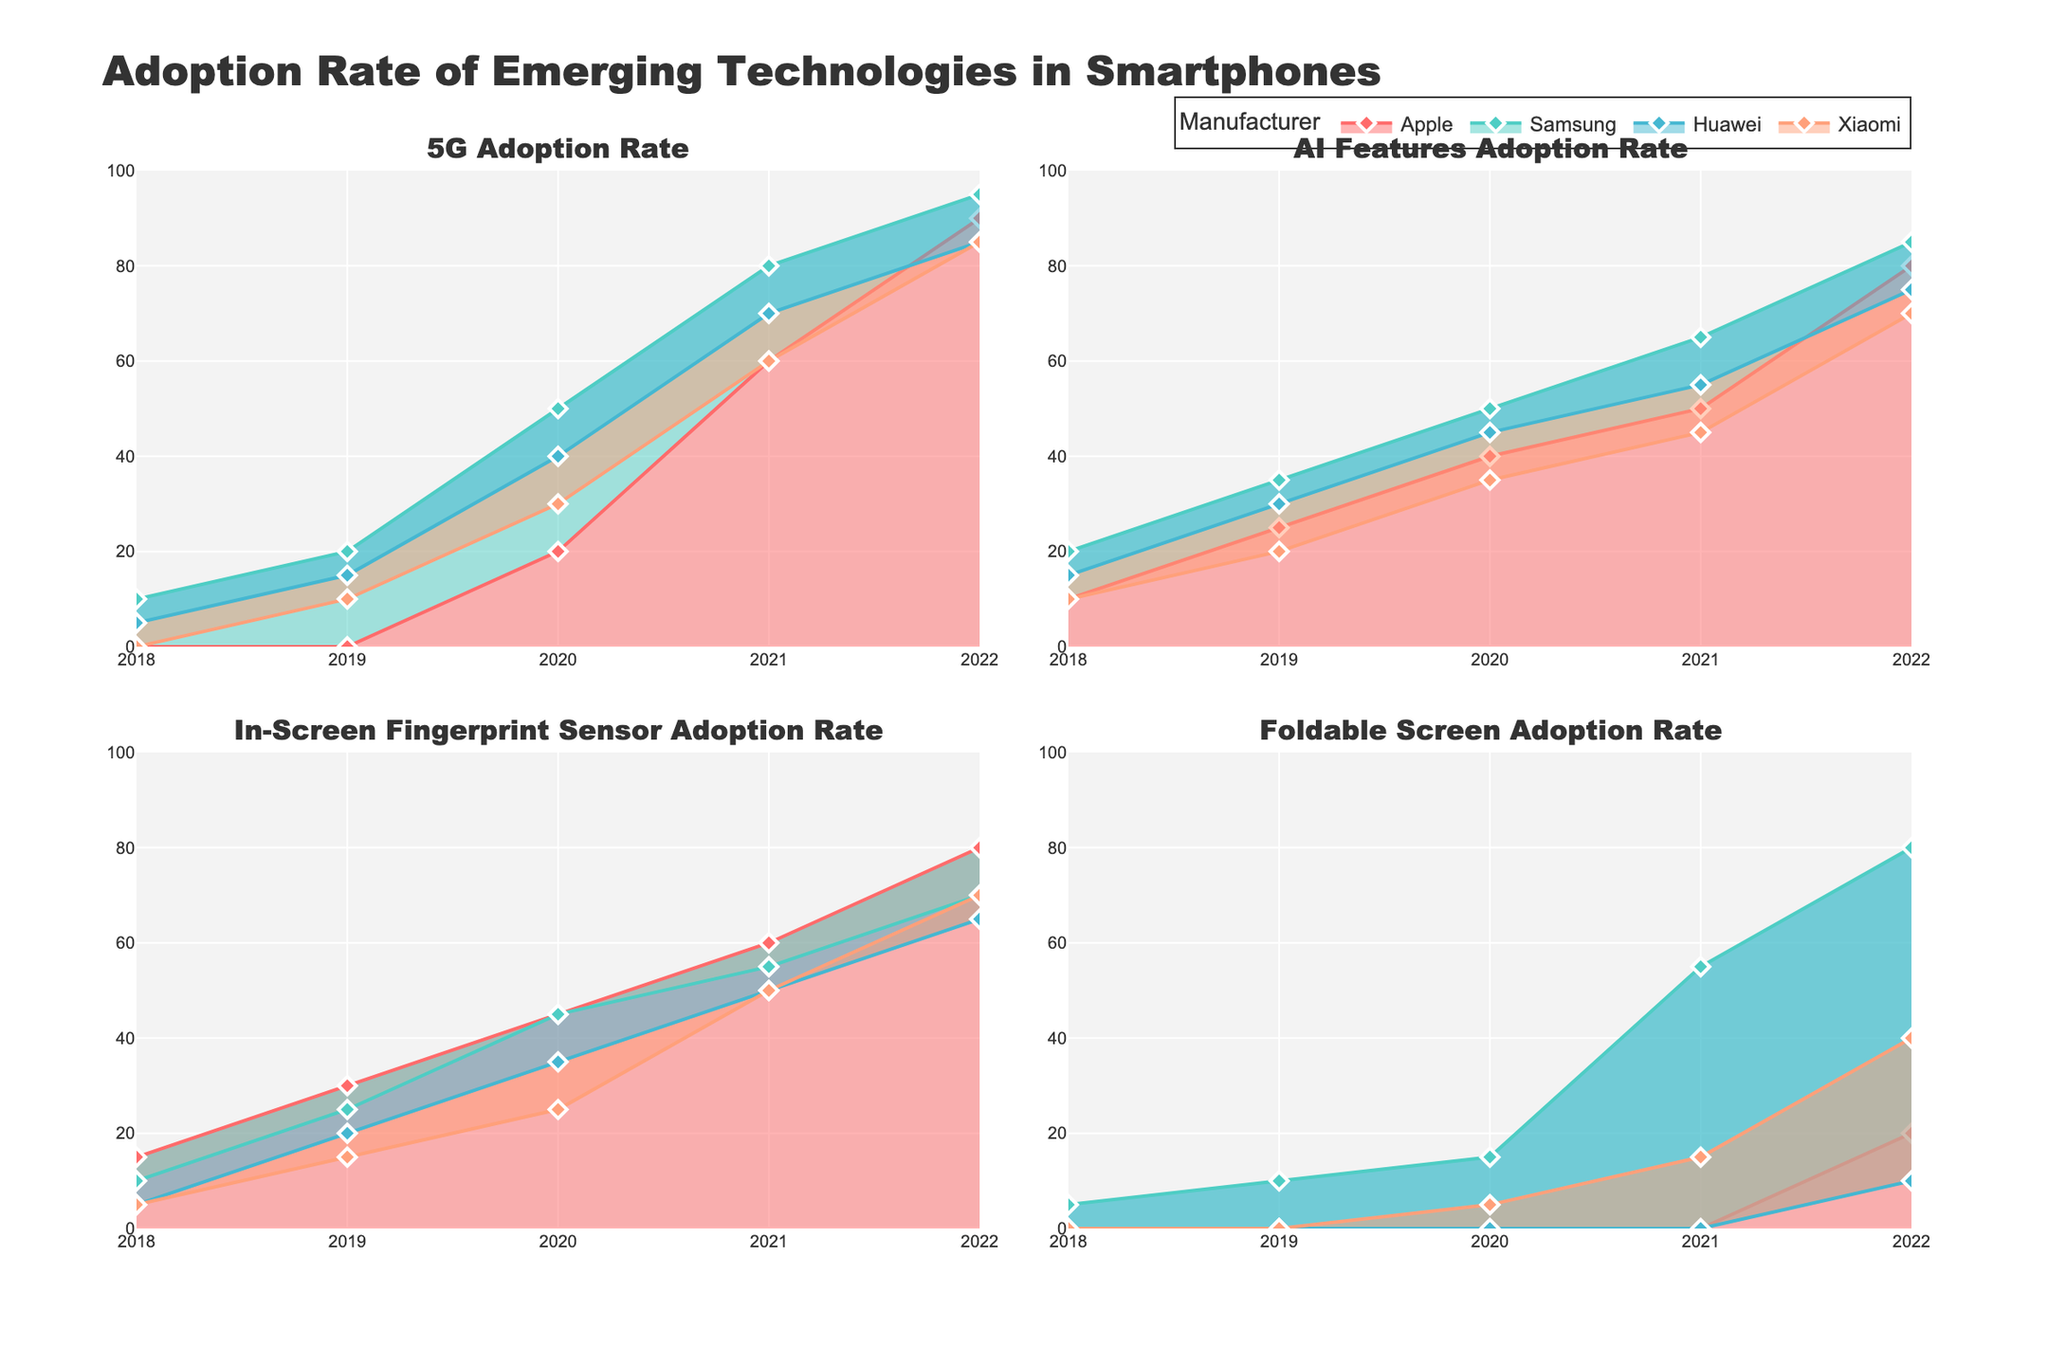Which manufacturer had the highest 5G adoption rate in 2022? By looking at the 5G Adoption Rate subplot, focus on the year 2022 and compare all manufacturers. Samsung has the highest peak at that year.
Answer: Samsung What was the trend in AI Features Adoption Rate for Apple over the last 5 years? Focus on the AI Features Adoption Rate subplot for Apple. Over 5 years, Apple shows a gradual increase, starting from 10% in 2018 and reaching up to 80% in 2022.
Answer: Gradual increase Among the four manufacturers, which one was the first to adopt Foldable Screen technology? Check the Foldable Screen Adoption Rate subplot and look for the earliest year where there is a non-zero adoption rate. Samsung has a non-zero data point in 2018.
Answer: Samsung What is the difference in 5G adoption rate between Samsung and Huawei in 2020? Find the 5G Adoption Rate for both Samsung and Huawei in 2020. Samsung's rate is 50% while Huawei's is 40%. Calculate the difference by subtracting Huawei's rate from Samsung's rate: 50% - 40% = 10%.
Answer: 10% Compare the trend in In-Screen Fingerprint Sensor Adoption Rate between Apple and Xiaomi. Look at the In-Screen Fingerprint Sensor Adoption Rate subplot for both Apple and Xiaomi. Apple starts higher but increases more steadily, while Xiaomi starts lower but catches up quickly from 2021 onwards.
Answer: Apple starts higher, Xiaomi catches up quickly What was the Foldable Screen adoption rate in 2021 among all four manufacturers, and which had the highest rate? Check the Foldable Screen Adoption Rate subplot for the year 2021. Apple: 0%, Samsung: 55%, Huawei: 0%, Xiaomi: 15%. Samsung had the highest rate.
Answer: Samsung, 55% Calculate the average 5G adoption rate for Apple across all 5 years. Note the 5G Adoption Rates for Apple: 0%, 0%, 20%, 60%, 90%. Sum these values and divide by 5. (0 + 0 + 20 + 60 + 90) / 5 = 34%.
Answer: 34% How did Huawei's AI Features Adoption Rate change between 2018 and 2022? Look at Huawei's AI Features Adoption Rate subplot and compare the values in 2018 (15%) and 2022 (75%). This shows an increase of 60%.
Answer: Increase by 60% Which manufacturer had the lowest In-Screen Fingerprint Sensor Adoption Rate in 2019? Find the data points for In-Screen Fingerprint Sensor Adoption Rate in 2019. Apple: 30%, Samsung: 25%, Huawei: 20%, Xiaomi: 15%. Xiaomi has the lowest rate.
Answer: Xiaomi Is there a manufacturer that adopted foldable screen technology later than others but showed high adoption rates later on? Look at the Foldable Screen Adoption Rate subplot. Xiaomi adopted in 2020 but showed high adoption rates in subsequent years (15% in 2021, 40% in 2022).
Answer: Yes, Xiaomi 